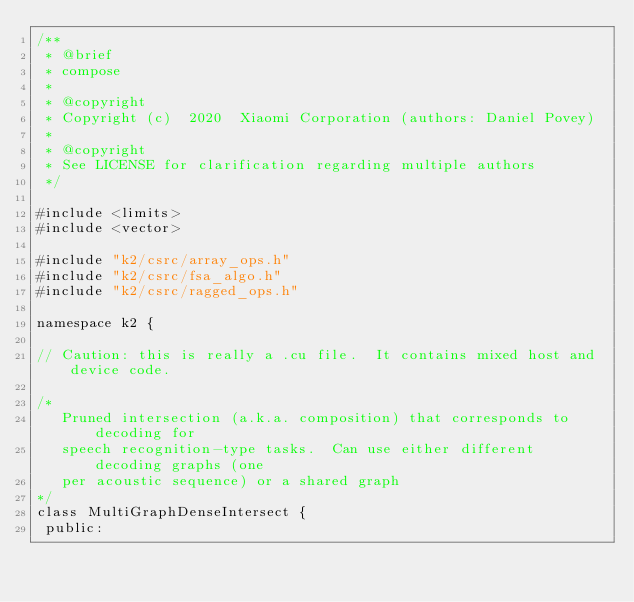<code> <loc_0><loc_0><loc_500><loc_500><_Cuda_>/**
 * @brief
 * compose
 *
 * @copyright
 * Copyright (c)  2020  Xiaomi Corporation (authors: Daniel Povey)
 *
 * @copyright
 * See LICENSE for clarification regarding multiple authors
 */

#include <limits>
#include <vector>

#include "k2/csrc/array_ops.h"
#include "k2/csrc/fsa_algo.h"
#include "k2/csrc/ragged_ops.h"

namespace k2 {

// Caution: this is really a .cu file.  It contains mixed host and device code.

/*
   Pruned intersection (a.k.a. composition) that corresponds to decoding for
   speech recognition-type tasks.  Can use either different decoding graphs (one
   per acoustic sequence) or a shared graph
*/
class MultiGraphDenseIntersect {
 public:</code> 